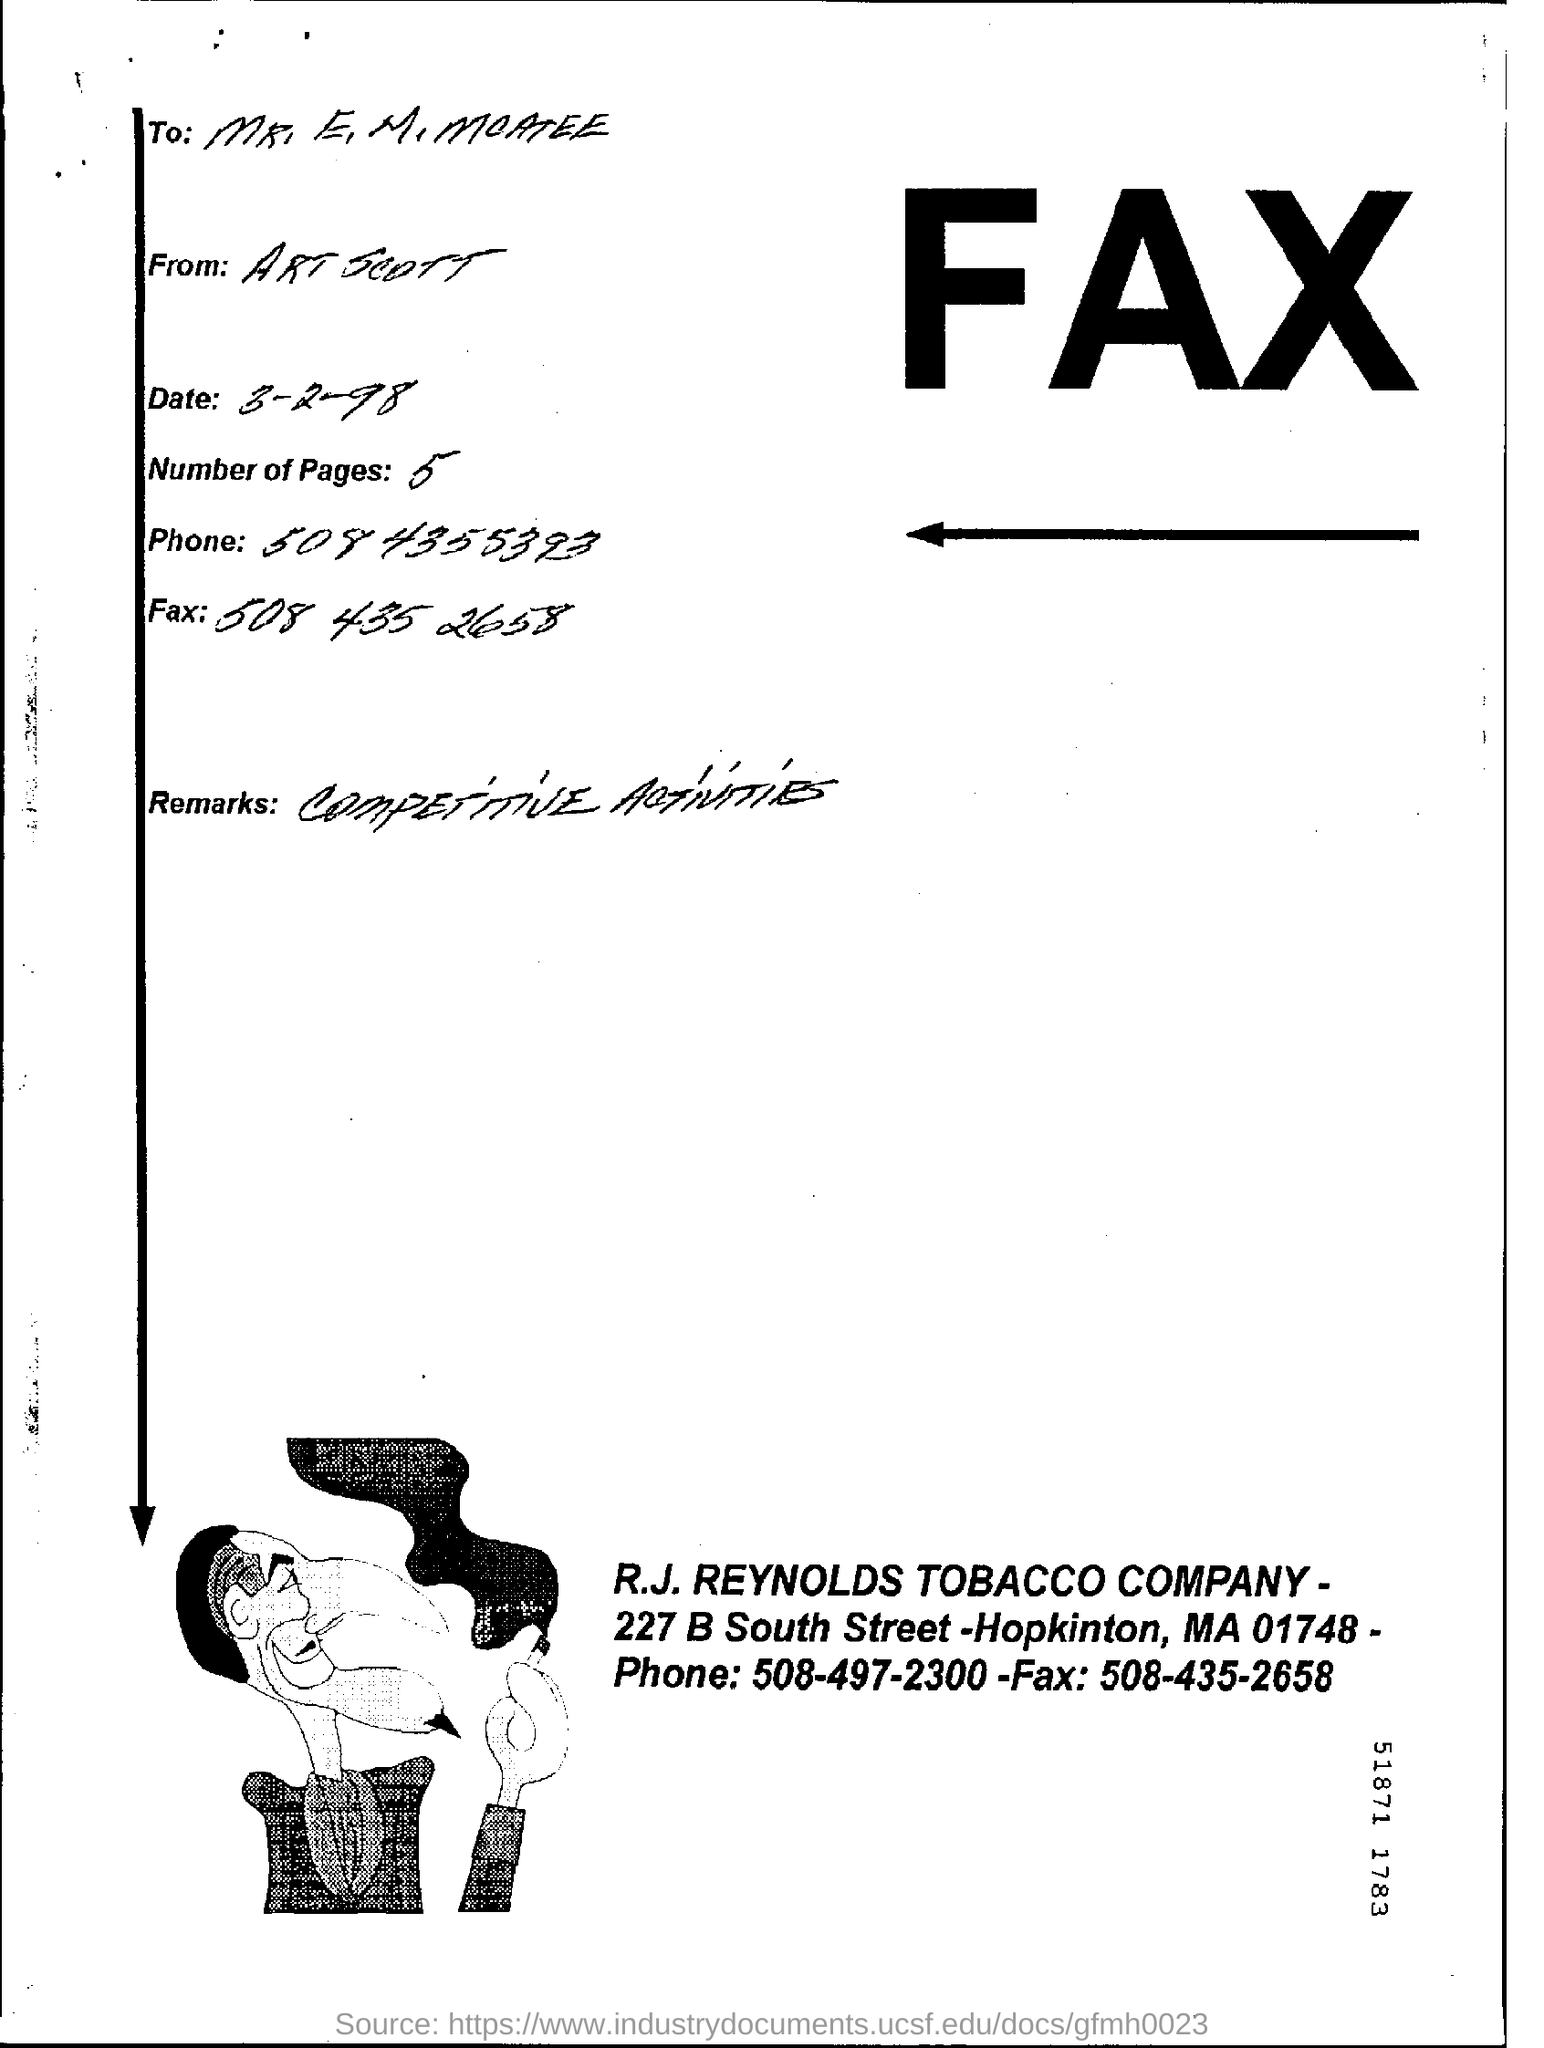Indicate a few pertinent items in this graphic. The fax was sent on March 2, 1998. There are five pages. The R.J. REYNOLDS TOBACCO COMPANY is mentioned in the document. 